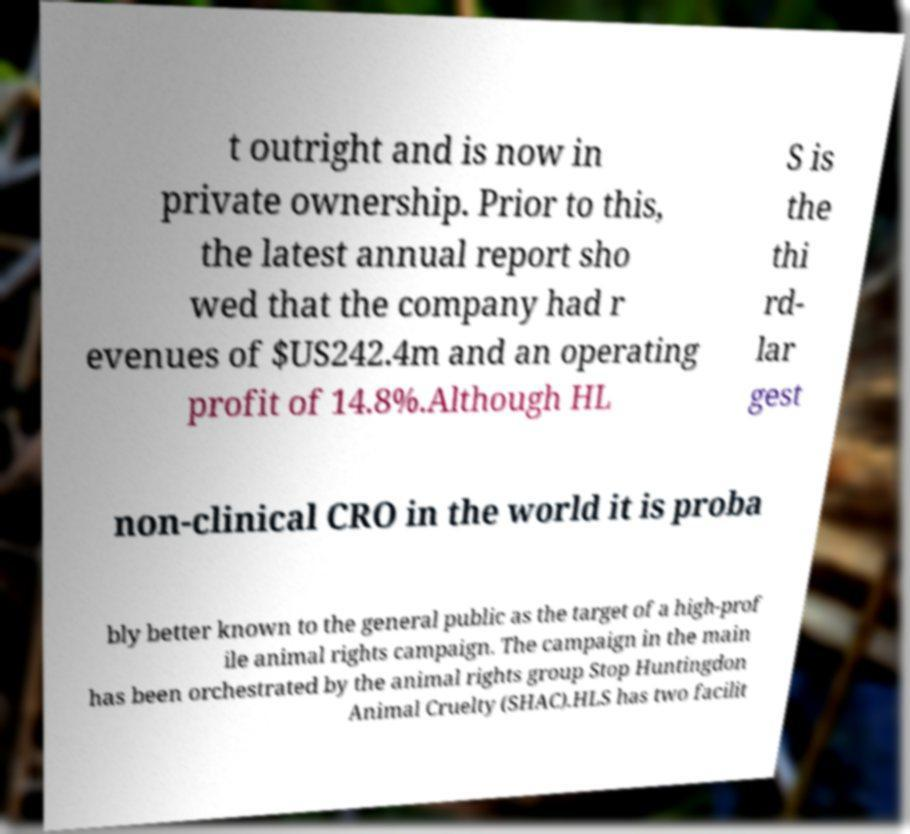Please identify and transcribe the text found in this image. t outright and is now in private ownership. Prior to this, the latest annual report sho wed that the company had r evenues of $US242.4m and an operating profit of 14.8%.Although HL S is the thi rd- lar gest non-clinical CRO in the world it is proba bly better known to the general public as the target of a high-prof ile animal rights campaign. The campaign in the main has been orchestrated by the animal rights group Stop Huntingdon Animal Cruelty (SHAC).HLS has two facilit 